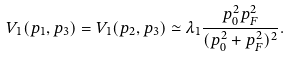<formula> <loc_0><loc_0><loc_500><loc_500>V _ { 1 } ( p _ { 1 } , p _ { 3 } ) = V _ { 1 } ( p _ { 2 } , p _ { 3 } ) \simeq \lambda _ { 1 } \frac { p _ { 0 } ^ { 2 } p _ { F } ^ { 2 } } { ( p _ { 0 } ^ { 2 } + p _ { F } ^ { 2 } ) ^ { 2 } } .</formula> 